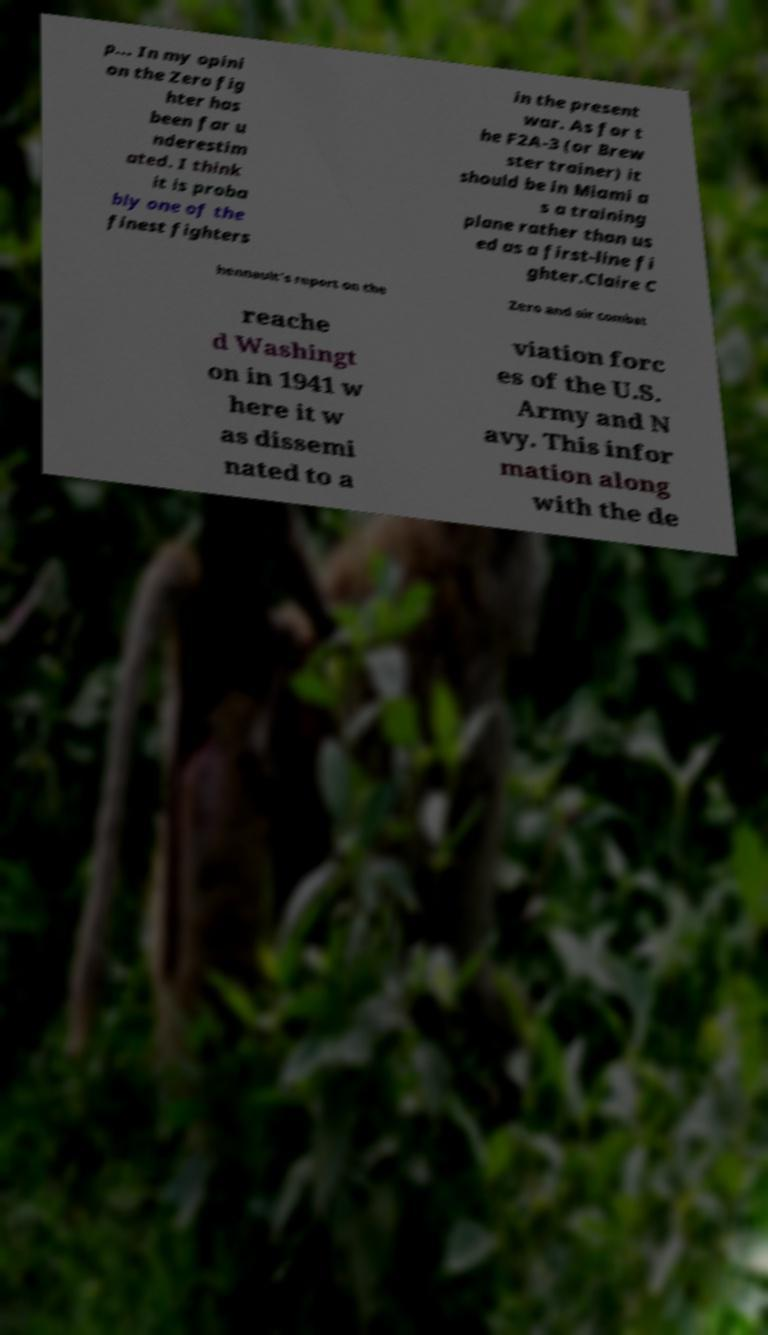Please identify and transcribe the text found in this image. p... In my opini on the Zero fig hter has been far u nderestim ated. I think it is proba bly one of the finest fighters in the present war. As for t he F2A-3 (or Brew ster trainer) it should be in Miami a s a training plane rather than us ed as a first-line fi ghter.Claire C hennault's report on the Zero and air combat reache d Washingt on in 1941 w here it w as dissemi nated to a viation forc es of the U.S. Army and N avy. This infor mation along with the de 